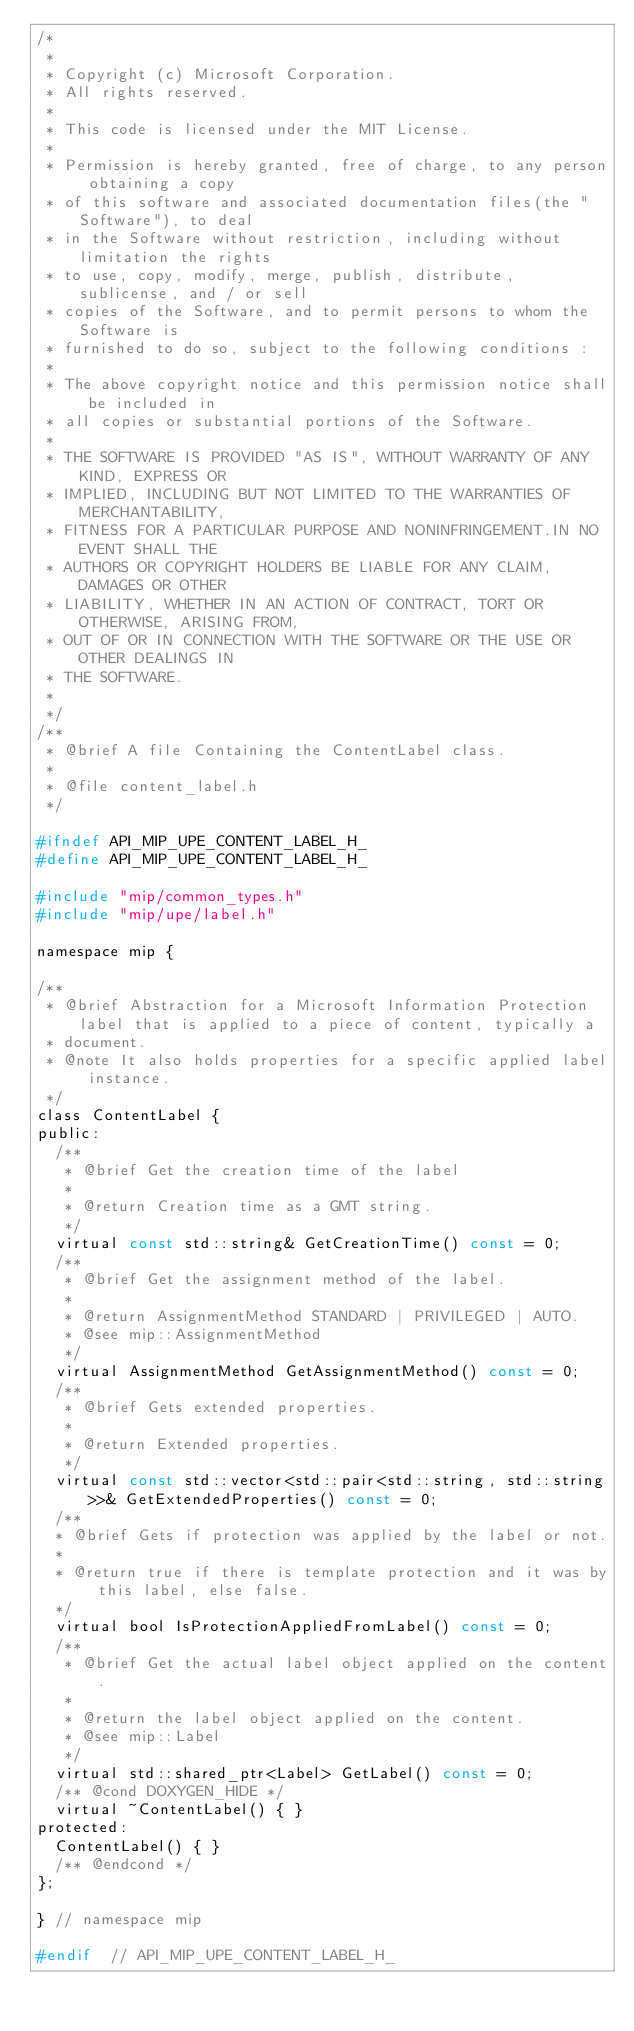Convert code to text. <code><loc_0><loc_0><loc_500><loc_500><_C_>/*
 *
 * Copyright (c) Microsoft Corporation.
 * All rights reserved.
 *
 * This code is licensed under the MIT License.
 *
 * Permission is hereby granted, free of charge, to any person obtaining a copy
 * of this software and associated documentation files(the "Software"), to deal
 * in the Software without restriction, including without limitation the rights
 * to use, copy, modify, merge, publish, distribute, sublicense, and / or sell
 * copies of the Software, and to permit persons to whom the Software is
 * furnished to do so, subject to the following conditions :
 *
 * The above copyright notice and this permission notice shall be included in
 * all copies or substantial portions of the Software.
 *
 * THE SOFTWARE IS PROVIDED "AS IS", WITHOUT WARRANTY OF ANY KIND, EXPRESS OR
 * IMPLIED, INCLUDING BUT NOT LIMITED TO THE WARRANTIES OF MERCHANTABILITY,
 * FITNESS FOR A PARTICULAR PURPOSE AND NONINFRINGEMENT.IN NO EVENT SHALL THE
 * AUTHORS OR COPYRIGHT HOLDERS BE LIABLE FOR ANY CLAIM, DAMAGES OR OTHER
 * LIABILITY, WHETHER IN AN ACTION OF CONTRACT, TORT OR OTHERWISE, ARISING FROM,
 * OUT OF OR IN CONNECTION WITH THE SOFTWARE OR THE USE OR OTHER DEALINGS IN
 * THE SOFTWARE.
 *
 */
/**
 * @brief A file Containing the ContentLabel class.
 * 
 * @file content_label.h
 */

#ifndef API_MIP_UPE_CONTENT_LABEL_H_
#define API_MIP_UPE_CONTENT_LABEL_H_

#include "mip/common_types.h"
#include "mip/upe/label.h"

namespace mip {

/**
 * @brief Abstraction for a Microsoft Information Protection label that is applied to a piece of content, typically a
 * document.
 * @note It also holds properties for a specific applied label instance.
 */
class ContentLabel {
public:
  /**
   * @brief Get the creation time of the label
   * 
   * @return Creation time as a GMT string.
   */
  virtual const std::string& GetCreationTime() const = 0;
  /**
   * @brief Get the assignment method of the label. 
   * 
   * @return AssignmentMethod STANDARD | PRIVILEGED | AUTO.
   * @see mip::AssignmentMethod
   */
  virtual AssignmentMethod GetAssignmentMethod() const = 0;
  /**
   * @brief Gets extended properties.
   * 
   * @return Extended properties.
   */
  virtual const std::vector<std::pair<std::string, std::string>>& GetExtendedProperties() const = 0;
  /**
  * @brief Gets if protection was applied by the label or not.
  *
  * @return true if there is template protection and it was by this label, else false.
  */
  virtual bool IsProtectionAppliedFromLabel() const = 0;
  /**
   * @brief Get the actual label object applied on the content.
   * 
   * @return the label object applied on the content.
   * @see mip::Label
   */
  virtual std::shared_ptr<Label> GetLabel() const = 0;
  /** @cond DOXYGEN_HIDE */
  virtual ~ContentLabel() { }
protected:
  ContentLabel() { }
  /** @endcond */
};

} // namespace mip

#endif  // API_MIP_UPE_CONTENT_LABEL_H_</code> 